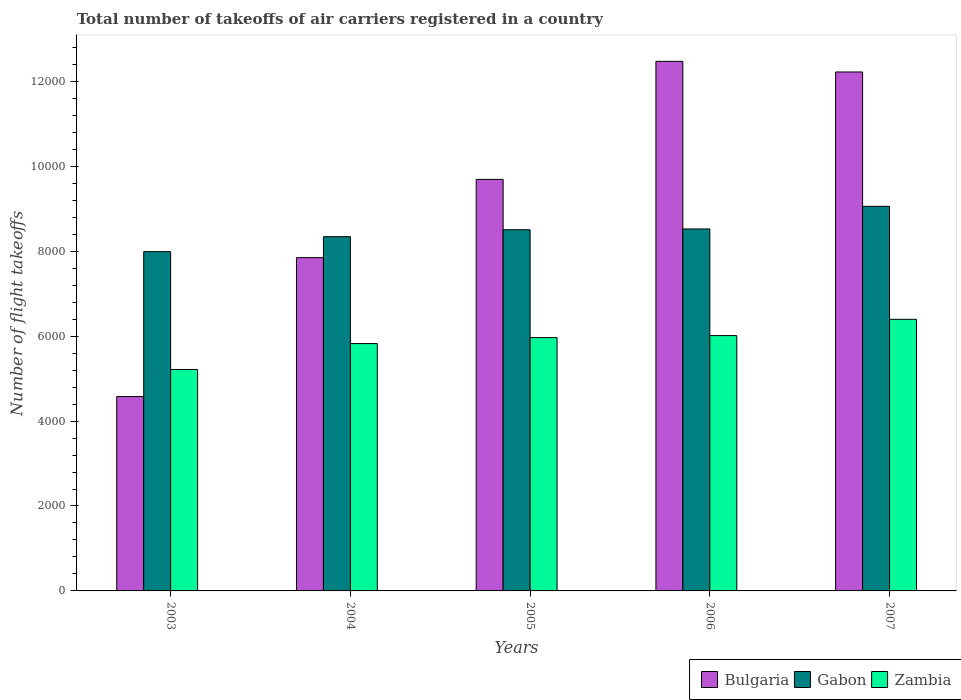How many groups of bars are there?
Provide a succinct answer. 5. Are the number of bars per tick equal to the number of legend labels?
Provide a succinct answer. Yes. Are the number of bars on each tick of the X-axis equal?
Provide a succinct answer. Yes. How many bars are there on the 2nd tick from the left?
Ensure brevity in your answer.  3. What is the total number of flight takeoffs in Gabon in 2007?
Your response must be concise. 9057. Across all years, what is the maximum total number of flight takeoffs in Gabon?
Give a very brief answer. 9057. Across all years, what is the minimum total number of flight takeoffs in Gabon?
Your answer should be very brief. 7990. In which year was the total number of flight takeoffs in Gabon maximum?
Your answer should be compact. 2007. In which year was the total number of flight takeoffs in Zambia minimum?
Provide a short and direct response. 2003. What is the total total number of flight takeoffs in Bulgaria in the graph?
Make the answer very short. 4.68e+04. What is the difference between the total number of flight takeoffs in Gabon in 2003 and that in 2006?
Ensure brevity in your answer.  -534. What is the difference between the total number of flight takeoffs in Bulgaria in 2003 and the total number of flight takeoffs in Gabon in 2004?
Ensure brevity in your answer.  -3765. What is the average total number of flight takeoffs in Gabon per year?
Offer a very short reply. 8483.6. In the year 2005, what is the difference between the total number of flight takeoffs in Bulgaria and total number of flight takeoffs in Zambia?
Your answer should be compact. 3726. What is the ratio of the total number of flight takeoffs in Bulgaria in 2004 to that in 2006?
Provide a succinct answer. 0.63. Is the total number of flight takeoffs in Zambia in 2004 less than that in 2005?
Provide a short and direct response. Yes. Is the difference between the total number of flight takeoffs in Bulgaria in 2004 and 2006 greater than the difference between the total number of flight takeoffs in Zambia in 2004 and 2006?
Provide a succinct answer. No. What is the difference between the highest and the second highest total number of flight takeoffs in Bulgaria?
Keep it short and to the point. 250. What is the difference between the highest and the lowest total number of flight takeoffs in Bulgaria?
Give a very brief answer. 7894. What does the 2nd bar from the left in 2004 represents?
Offer a terse response. Gabon. What does the 1st bar from the right in 2003 represents?
Ensure brevity in your answer.  Zambia. Is it the case that in every year, the sum of the total number of flight takeoffs in Bulgaria and total number of flight takeoffs in Zambia is greater than the total number of flight takeoffs in Gabon?
Ensure brevity in your answer.  Yes. How many bars are there?
Your answer should be very brief. 15. Are all the bars in the graph horizontal?
Your answer should be very brief. No. How many years are there in the graph?
Make the answer very short. 5. Does the graph contain any zero values?
Your answer should be compact. No. Does the graph contain grids?
Offer a very short reply. No. How many legend labels are there?
Provide a short and direct response. 3. How are the legend labels stacked?
Your answer should be very brief. Horizontal. What is the title of the graph?
Offer a very short reply. Total number of takeoffs of air carriers registered in a country. Does "Eritrea" appear as one of the legend labels in the graph?
Your response must be concise. No. What is the label or title of the Y-axis?
Make the answer very short. Number of flight takeoffs. What is the Number of flight takeoffs in Bulgaria in 2003?
Ensure brevity in your answer.  4577. What is the Number of flight takeoffs in Gabon in 2003?
Give a very brief answer. 7990. What is the Number of flight takeoffs of Zambia in 2003?
Your answer should be very brief. 5214. What is the Number of flight takeoffs in Bulgaria in 2004?
Offer a terse response. 7848. What is the Number of flight takeoffs in Gabon in 2004?
Your response must be concise. 8342. What is the Number of flight takeoffs in Zambia in 2004?
Your answer should be compact. 5825. What is the Number of flight takeoffs in Bulgaria in 2005?
Your answer should be very brief. 9691. What is the Number of flight takeoffs of Gabon in 2005?
Provide a succinct answer. 8505. What is the Number of flight takeoffs of Zambia in 2005?
Provide a short and direct response. 5965. What is the Number of flight takeoffs of Bulgaria in 2006?
Ensure brevity in your answer.  1.25e+04. What is the Number of flight takeoffs in Gabon in 2006?
Ensure brevity in your answer.  8524. What is the Number of flight takeoffs in Zambia in 2006?
Give a very brief answer. 6013. What is the Number of flight takeoffs in Bulgaria in 2007?
Keep it short and to the point. 1.22e+04. What is the Number of flight takeoffs in Gabon in 2007?
Keep it short and to the point. 9057. What is the Number of flight takeoffs in Zambia in 2007?
Your answer should be very brief. 6396. Across all years, what is the maximum Number of flight takeoffs in Bulgaria?
Provide a succinct answer. 1.25e+04. Across all years, what is the maximum Number of flight takeoffs in Gabon?
Your answer should be compact. 9057. Across all years, what is the maximum Number of flight takeoffs of Zambia?
Offer a terse response. 6396. Across all years, what is the minimum Number of flight takeoffs in Bulgaria?
Give a very brief answer. 4577. Across all years, what is the minimum Number of flight takeoffs of Gabon?
Your response must be concise. 7990. Across all years, what is the minimum Number of flight takeoffs in Zambia?
Offer a terse response. 5214. What is the total Number of flight takeoffs of Bulgaria in the graph?
Keep it short and to the point. 4.68e+04. What is the total Number of flight takeoffs of Gabon in the graph?
Make the answer very short. 4.24e+04. What is the total Number of flight takeoffs of Zambia in the graph?
Your response must be concise. 2.94e+04. What is the difference between the Number of flight takeoffs of Bulgaria in 2003 and that in 2004?
Offer a very short reply. -3271. What is the difference between the Number of flight takeoffs in Gabon in 2003 and that in 2004?
Provide a succinct answer. -352. What is the difference between the Number of flight takeoffs of Zambia in 2003 and that in 2004?
Give a very brief answer. -611. What is the difference between the Number of flight takeoffs of Bulgaria in 2003 and that in 2005?
Give a very brief answer. -5114. What is the difference between the Number of flight takeoffs of Gabon in 2003 and that in 2005?
Ensure brevity in your answer.  -515. What is the difference between the Number of flight takeoffs of Zambia in 2003 and that in 2005?
Your response must be concise. -751. What is the difference between the Number of flight takeoffs in Bulgaria in 2003 and that in 2006?
Ensure brevity in your answer.  -7894. What is the difference between the Number of flight takeoffs in Gabon in 2003 and that in 2006?
Make the answer very short. -534. What is the difference between the Number of flight takeoffs of Zambia in 2003 and that in 2006?
Your answer should be very brief. -799. What is the difference between the Number of flight takeoffs of Bulgaria in 2003 and that in 2007?
Offer a very short reply. -7644. What is the difference between the Number of flight takeoffs in Gabon in 2003 and that in 2007?
Offer a very short reply. -1067. What is the difference between the Number of flight takeoffs of Zambia in 2003 and that in 2007?
Ensure brevity in your answer.  -1182. What is the difference between the Number of flight takeoffs in Bulgaria in 2004 and that in 2005?
Give a very brief answer. -1843. What is the difference between the Number of flight takeoffs of Gabon in 2004 and that in 2005?
Keep it short and to the point. -163. What is the difference between the Number of flight takeoffs in Zambia in 2004 and that in 2005?
Your answer should be compact. -140. What is the difference between the Number of flight takeoffs of Bulgaria in 2004 and that in 2006?
Ensure brevity in your answer.  -4623. What is the difference between the Number of flight takeoffs of Gabon in 2004 and that in 2006?
Make the answer very short. -182. What is the difference between the Number of flight takeoffs of Zambia in 2004 and that in 2006?
Give a very brief answer. -188. What is the difference between the Number of flight takeoffs of Bulgaria in 2004 and that in 2007?
Offer a very short reply. -4373. What is the difference between the Number of flight takeoffs of Gabon in 2004 and that in 2007?
Provide a succinct answer. -715. What is the difference between the Number of flight takeoffs in Zambia in 2004 and that in 2007?
Ensure brevity in your answer.  -571. What is the difference between the Number of flight takeoffs in Bulgaria in 2005 and that in 2006?
Your response must be concise. -2780. What is the difference between the Number of flight takeoffs in Zambia in 2005 and that in 2006?
Your answer should be compact. -48. What is the difference between the Number of flight takeoffs in Bulgaria in 2005 and that in 2007?
Your answer should be very brief. -2530. What is the difference between the Number of flight takeoffs in Gabon in 2005 and that in 2007?
Give a very brief answer. -552. What is the difference between the Number of flight takeoffs of Zambia in 2005 and that in 2007?
Keep it short and to the point. -431. What is the difference between the Number of flight takeoffs in Bulgaria in 2006 and that in 2007?
Provide a short and direct response. 250. What is the difference between the Number of flight takeoffs of Gabon in 2006 and that in 2007?
Your answer should be very brief. -533. What is the difference between the Number of flight takeoffs of Zambia in 2006 and that in 2007?
Give a very brief answer. -383. What is the difference between the Number of flight takeoffs of Bulgaria in 2003 and the Number of flight takeoffs of Gabon in 2004?
Keep it short and to the point. -3765. What is the difference between the Number of flight takeoffs in Bulgaria in 2003 and the Number of flight takeoffs in Zambia in 2004?
Keep it short and to the point. -1248. What is the difference between the Number of flight takeoffs in Gabon in 2003 and the Number of flight takeoffs in Zambia in 2004?
Provide a short and direct response. 2165. What is the difference between the Number of flight takeoffs in Bulgaria in 2003 and the Number of flight takeoffs in Gabon in 2005?
Provide a succinct answer. -3928. What is the difference between the Number of flight takeoffs in Bulgaria in 2003 and the Number of flight takeoffs in Zambia in 2005?
Your answer should be compact. -1388. What is the difference between the Number of flight takeoffs in Gabon in 2003 and the Number of flight takeoffs in Zambia in 2005?
Provide a short and direct response. 2025. What is the difference between the Number of flight takeoffs of Bulgaria in 2003 and the Number of flight takeoffs of Gabon in 2006?
Provide a succinct answer. -3947. What is the difference between the Number of flight takeoffs of Bulgaria in 2003 and the Number of flight takeoffs of Zambia in 2006?
Offer a very short reply. -1436. What is the difference between the Number of flight takeoffs in Gabon in 2003 and the Number of flight takeoffs in Zambia in 2006?
Your answer should be compact. 1977. What is the difference between the Number of flight takeoffs of Bulgaria in 2003 and the Number of flight takeoffs of Gabon in 2007?
Ensure brevity in your answer.  -4480. What is the difference between the Number of flight takeoffs of Bulgaria in 2003 and the Number of flight takeoffs of Zambia in 2007?
Your response must be concise. -1819. What is the difference between the Number of flight takeoffs in Gabon in 2003 and the Number of flight takeoffs in Zambia in 2007?
Keep it short and to the point. 1594. What is the difference between the Number of flight takeoffs of Bulgaria in 2004 and the Number of flight takeoffs of Gabon in 2005?
Offer a terse response. -657. What is the difference between the Number of flight takeoffs in Bulgaria in 2004 and the Number of flight takeoffs in Zambia in 2005?
Your answer should be compact. 1883. What is the difference between the Number of flight takeoffs in Gabon in 2004 and the Number of flight takeoffs in Zambia in 2005?
Keep it short and to the point. 2377. What is the difference between the Number of flight takeoffs of Bulgaria in 2004 and the Number of flight takeoffs of Gabon in 2006?
Provide a short and direct response. -676. What is the difference between the Number of flight takeoffs in Bulgaria in 2004 and the Number of flight takeoffs in Zambia in 2006?
Offer a terse response. 1835. What is the difference between the Number of flight takeoffs of Gabon in 2004 and the Number of flight takeoffs of Zambia in 2006?
Your response must be concise. 2329. What is the difference between the Number of flight takeoffs in Bulgaria in 2004 and the Number of flight takeoffs in Gabon in 2007?
Give a very brief answer. -1209. What is the difference between the Number of flight takeoffs in Bulgaria in 2004 and the Number of flight takeoffs in Zambia in 2007?
Give a very brief answer. 1452. What is the difference between the Number of flight takeoffs of Gabon in 2004 and the Number of flight takeoffs of Zambia in 2007?
Your answer should be compact. 1946. What is the difference between the Number of flight takeoffs in Bulgaria in 2005 and the Number of flight takeoffs in Gabon in 2006?
Keep it short and to the point. 1167. What is the difference between the Number of flight takeoffs in Bulgaria in 2005 and the Number of flight takeoffs in Zambia in 2006?
Offer a very short reply. 3678. What is the difference between the Number of flight takeoffs in Gabon in 2005 and the Number of flight takeoffs in Zambia in 2006?
Give a very brief answer. 2492. What is the difference between the Number of flight takeoffs of Bulgaria in 2005 and the Number of flight takeoffs of Gabon in 2007?
Your answer should be very brief. 634. What is the difference between the Number of flight takeoffs in Bulgaria in 2005 and the Number of flight takeoffs in Zambia in 2007?
Offer a very short reply. 3295. What is the difference between the Number of flight takeoffs in Gabon in 2005 and the Number of flight takeoffs in Zambia in 2007?
Provide a short and direct response. 2109. What is the difference between the Number of flight takeoffs in Bulgaria in 2006 and the Number of flight takeoffs in Gabon in 2007?
Offer a terse response. 3414. What is the difference between the Number of flight takeoffs in Bulgaria in 2006 and the Number of flight takeoffs in Zambia in 2007?
Your response must be concise. 6075. What is the difference between the Number of flight takeoffs in Gabon in 2006 and the Number of flight takeoffs in Zambia in 2007?
Make the answer very short. 2128. What is the average Number of flight takeoffs of Bulgaria per year?
Your response must be concise. 9361.6. What is the average Number of flight takeoffs in Gabon per year?
Offer a terse response. 8483.6. What is the average Number of flight takeoffs in Zambia per year?
Your answer should be very brief. 5882.6. In the year 2003, what is the difference between the Number of flight takeoffs in Bulgaria and Number of flight takeoffs in Gabon?
Provide a short and direct response. -3413. In the year 2003, what is the difference between the Number of flight takeoffs in Bulgaria and Number of flight takeoffs in Zambia?
Provide a short and direct response. -637. In the year 2003, what is the difference between the Number of flight takeoffs of Gabon and Number of flight takeoffs of Zambia?
Keep it short and to the point. 2776. In the year 2004, what is the difference between the Number of flight takeoffs of Bulgaria and Number of flight takeoffs of Gabon?
Make the answer very short. -494. In the year 2004, what is the difference between the Number of flight takeoffs of Bulgaria and Number of flight takeoffs of Zambia?
Your response must be concise. 2023. In the year 2004, what is the difference between the Number of flight takeoffs in Gabon and Number of flight takeoffs in Zambia?
Keep it short and to the point. 2517. In the year 2005, what is the difference between the Number of flight takeoffs of Bulgaria and Number of flight takeoffs of Gabon?
Ensure brevity in your answer.  1186. In the year 2005, what is the difference between the Number of flight takeoffs of Bulgaria and Number of flight takeoffs of Zambia?
Provide a succinct answer. 3726. In the year 2005, what is the difference between the Number of flight takeoffs in Gabon and Number of flight takeoffs in Zambia?
Your answer should be compact. 2540. In the year 2006, what is the difference between the Number of flight takeoffs of Bulgaria and Number of flight takeoffs of Gabon?
Your response must be concise. 3947. In the year 2006, what is the difference between the Number of flight takeoffs of Bulgaria and Number of flight takeoffs of Zambia?
Your response must be concise. 6458. In the year 2006, what is the difference between the Number of flight takeoffs in Gabon and Number of flight takeoffs in Zambia?
Ensure brevity in your answer.  2511. In the year 2007, what is the difference between the Number of flight takeoffs of Bulgaria and Number of flight takeoffs of Gabon?
Provide a short and direct response. 3164. In the year 2007, what is the difference between the Number of flight takeoffs of Bulgaria and Number of flight takeoffs of Zambia?
Offer a terse response. 5825. In the year 2007, what is the difference between the Number of flight takeoffs in Gabon and Number of flight takeoffs in Zambia?
Offer a terse response. 2661. What is the ratio of the Number of flight takeoffs in Bulgaria in 2003 to that in 2004?
Your answer should be compact. 0.58. What is the ratio of the Number of flight takeoffs of Gabon in 2003 to that in 2004?
Your answer should be compact. 0.96. What is the ratio of the Number of flight takeoffs in Zambia in 2003 to that in 2004?
Your response must be concise. 0.9. What is the ratio of the Number of flight takeoffs of Bulgaria in 2003 to that in 2005?
Provide a succinct answer. 0.47. What is the ratio of the Number of flight takeoffs of Gabon in 2003 to that in 2005?
Give a very brief answer. 0.94. What is the ratio of the Number of flight takeoffs in Zambia in 2003 to that in 2005?
Your response must be concise. 0.87. What is the ratio of the Number of flight takeoffs in Bulgaria in 2003 to that in 2006?
Offer a terse response. 0.37. What is the ratio of the Number of flight takeoffs in Gabon in 2003 to that in 2006?
Provide a short and direct response. 0.94. What is the ratio of the Number of flight takeoffs of Zambia in 2003 to that in 2006?
Ensure brevity in your answer.  0.87. What is the ratio of the Number of flight takeoffs in Bulgaria in 2003 to that in 2007?
Provide a short and direct response. 0.37. What is the ratio of the Number of flight takeoffs in Gabon in 2003 to that in 2007?
Your response must be concise. 0.88. What is the ratio of the Number of flight takeoffs in Zambia in 2003 to that in 2007?
Offer a very short reply. 0.82. What is the ratio of the Number of flight takeoffs in Bulgaria in 2004 to that in 2005?
Provide a short and direct response. 0.81. What is the ratio of the Number of flight takeoffs of Gabon in 2004 to that in 2005?
Make the answer very short. 0.98. What is the ratio of the Number of flight takeoffs in Zambia in 2004 to that in 2005?
Offer a terse response. 0.98. What is the ratio of the Number of flight takeoffs in Bulgaria in 2004 to that in 2006?
Offer a very short reply. 0.63. What is the ratio of the Number of flight takeoffs of Gabon in 2004 to that in 2006?
Make the answer very short. 0.98. What is the ratio of the Number of flight takeoffs of Zambia in 2004 to that in 2006?
Your response must be concise. 0.97. What is the ratio of the Number of flight takeoffs in Bulgaria in 2004 to that in 2007?
Your answer should be very brief. 0.64. What is the ratio of the Number of flight takeoffs of Gabon in 2004 to that in 2007?
Your answer should be very brief. 0.92. What is the ratio of the Number of flight takeoffs of Zambia in 2004 to that in 2007?
Keep it short and to the point. 0.91. What is the ratio of the Number of flight takeoffs of Bulgaria in 2005 to that in 2006?
Keep it short and to the point. 0.78. What is the ratio of the Number of flight takeoffs in Bulgaria in 2005 to that in 2007?
Keep it short and to the point. 0.79. What is the ratio of the Number of flight takeoffs in Gabon in 2005 to that in 2007?
Give a very brief answer. 0.94. What is the ratio of the Number of flight takeoffs in Zambia in 2005 to that in 2007?
Give a very brief answer. 0.93. What is the ratio of the Number of flight takeoffs of Bulgaria in 2006 to that in 2007?
Provide a succinct answer. 1.02. What is the ratio of the Number of flight takeoffs in Gabon in 2006 to that in 2007?
Your response must be concise. 0.94. What is the ratio of the Number of flight takeoffs in Zambia in 2006 to that in 2007?
Your answer should be very brief. 0.94. What is the difference between the highest and the second highest Number of flight takeoffs of Bulgaria?
Offer a very short reply. 250. What is the difference between the highest and the second highest Number of flight takeoffs of Gabon?
Your answer should be very brief. 533. What is the difference between the highest and the second highest Number of flight takeoffs in Zambia?
Keep it short and to the point. 383. What is the difference between the highest and the lowest Number of flight takeoffs in Bulgaria?
Offer a terse response. 7894. What is the difference between the highest and the lowest Number of flight takeoffs of Gabon?
Your answer should be very brief. 1067. What is the difference between the highest and the lowest Number of flight takeoffs of Zambia?
Offer a very short reply. 1182. 